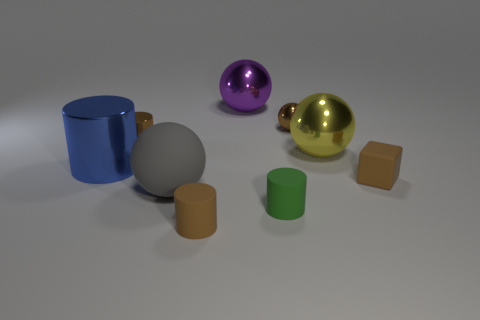Subtract 1 cylinders. How many cylinders are left? 3 Subtract all yellow cylinders. Subtract all green blocks. How many cylinders are left? 4 Add 1 big spheres. How many objects exist? 10 Subtract all cubes. How many objects are left? 8 Add 7 tiny green metallic things. How many tiny green metallic things exist? 7 Subtract 0 red cylinders. How many objects are left? 9 Subtract all cyan metal balls. Subtract all brown shiny cylinders. How many objects are left? 8 Add 8 green objects. How many green objects are left? 9 